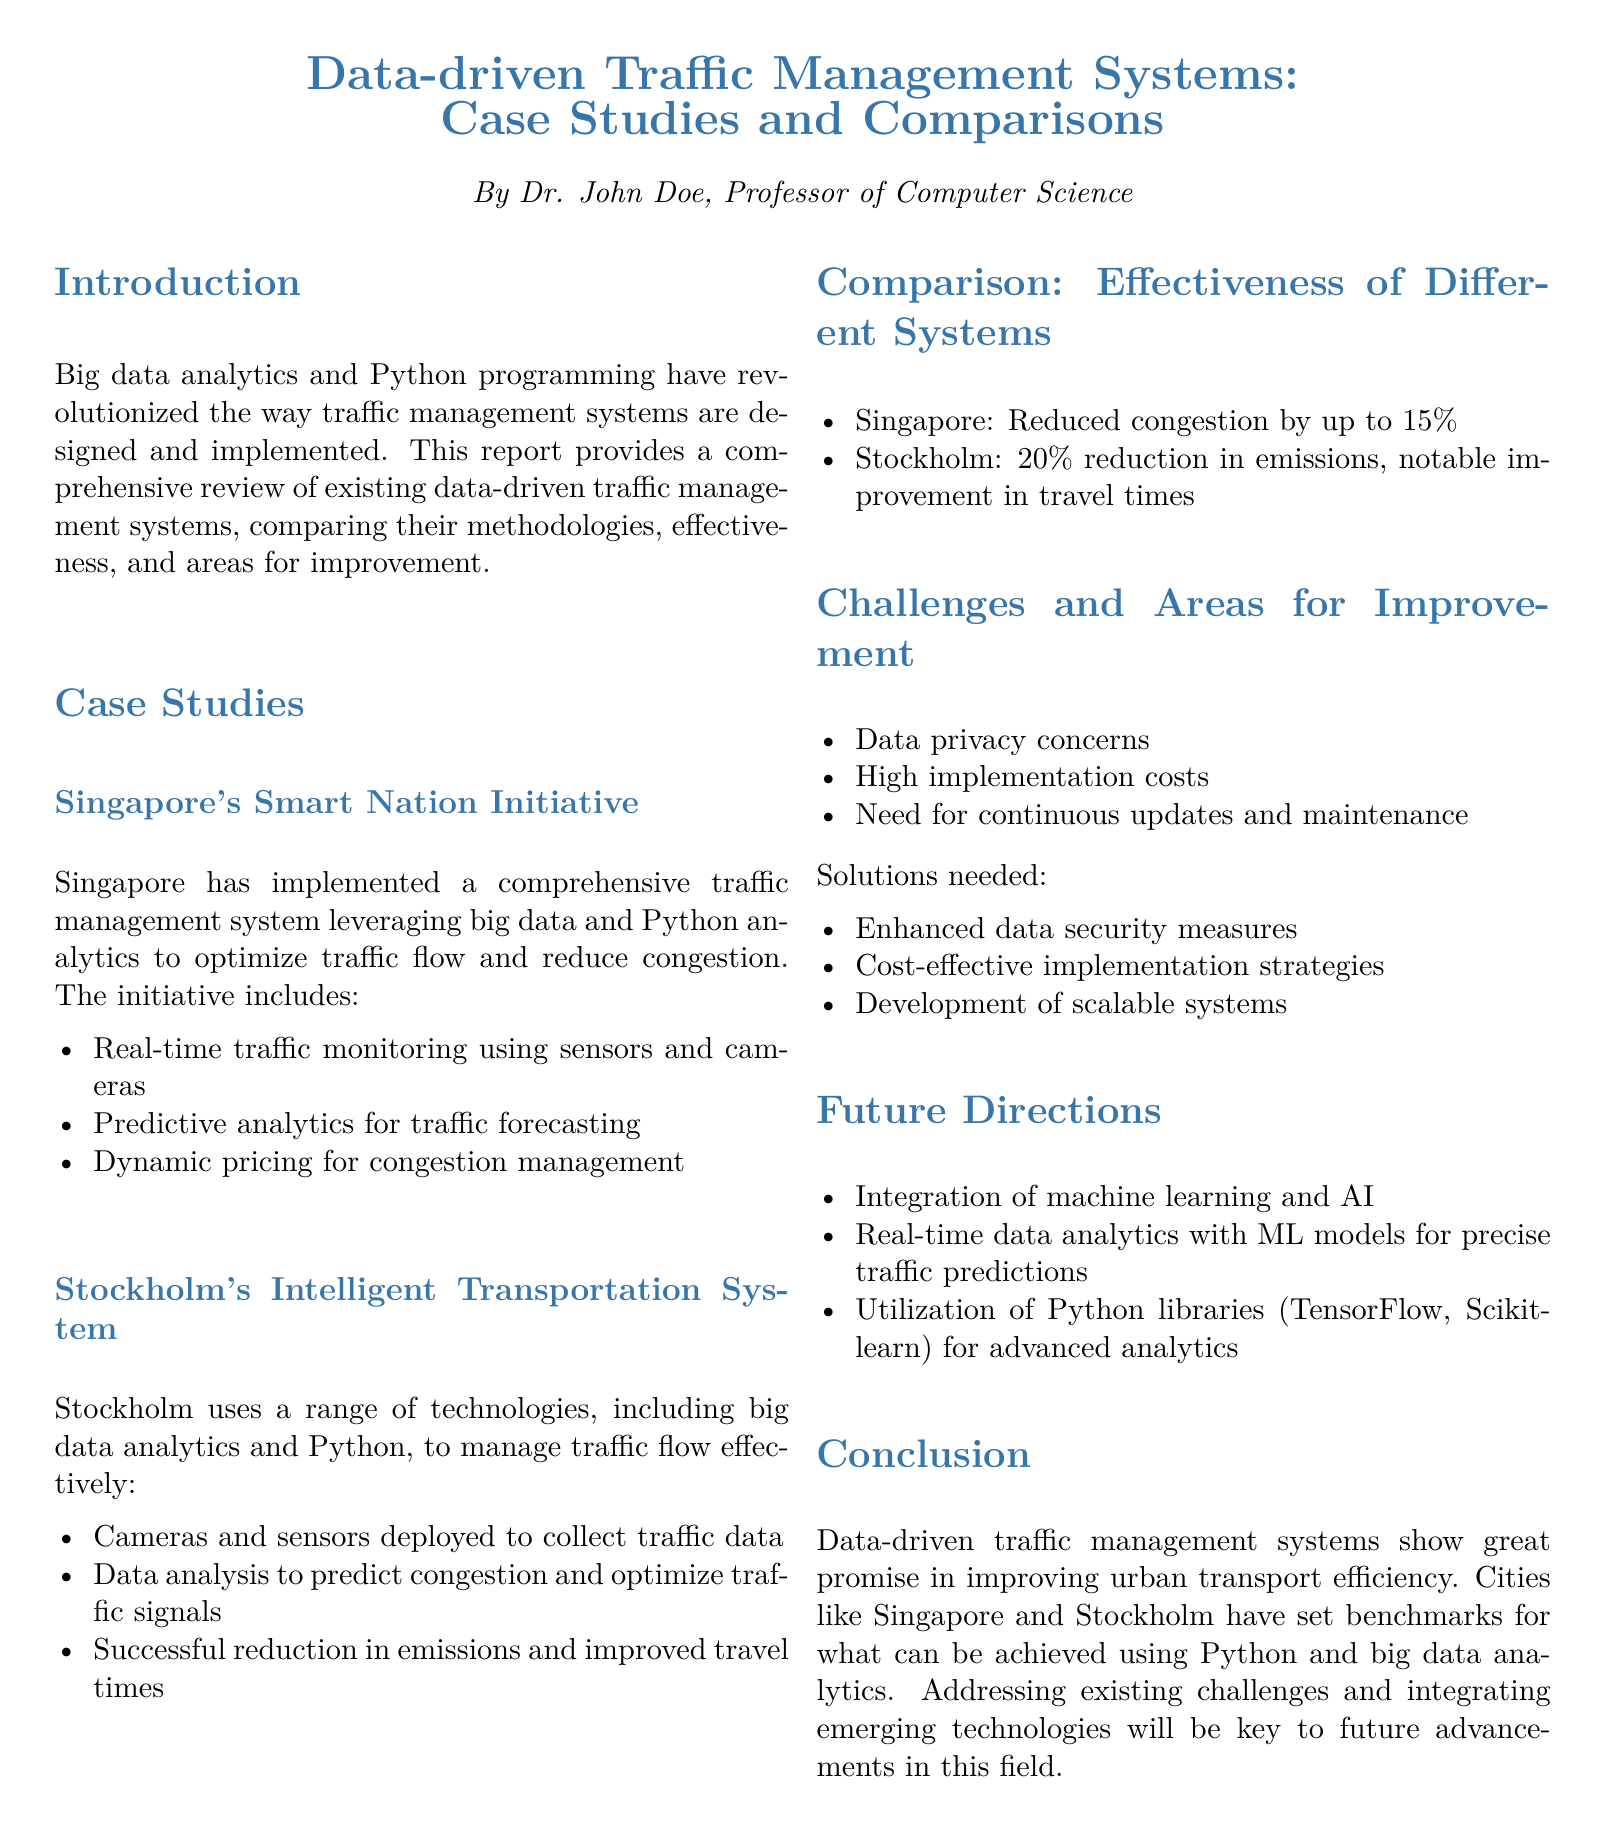What is the title of the report? The title is given prominently at the beginning of the document.
Answer: Data-driven Traffic Management Systems: Case Studies and Comparisons Who is the author of the report? The author is introduced in the introductory section of the document.
Answer: Dr. John Doe What technology does Singapore's initiative use for traffic monitoring? The document lists specific technologies used in the Singapore initiative.
Answer: Sensors and cameras By what percentage did Singapore reduce congestion? The effectiveness of the system in Singapore is mentioned in the comparison section.
Answer: 15% What is one challenge faced by traffic management systems according to the report? Challenges are clearly outlined in the document.
Answer: Data privacy concerns What future technology integration is suggested for traffic management systems? The future directions provide suggestions for upcoming technologies.
Answer: Machine learning and AI What is one Python library mentioned for advanced analytics? Specific libraries are referenced in the future directions section for analytics.
Answer: TensorFlow What percentage reduction in emissions was achieved in Stockholm? The effectiveness of Stockholm's system is highlighted in the comparison section.
Answer: 20% 